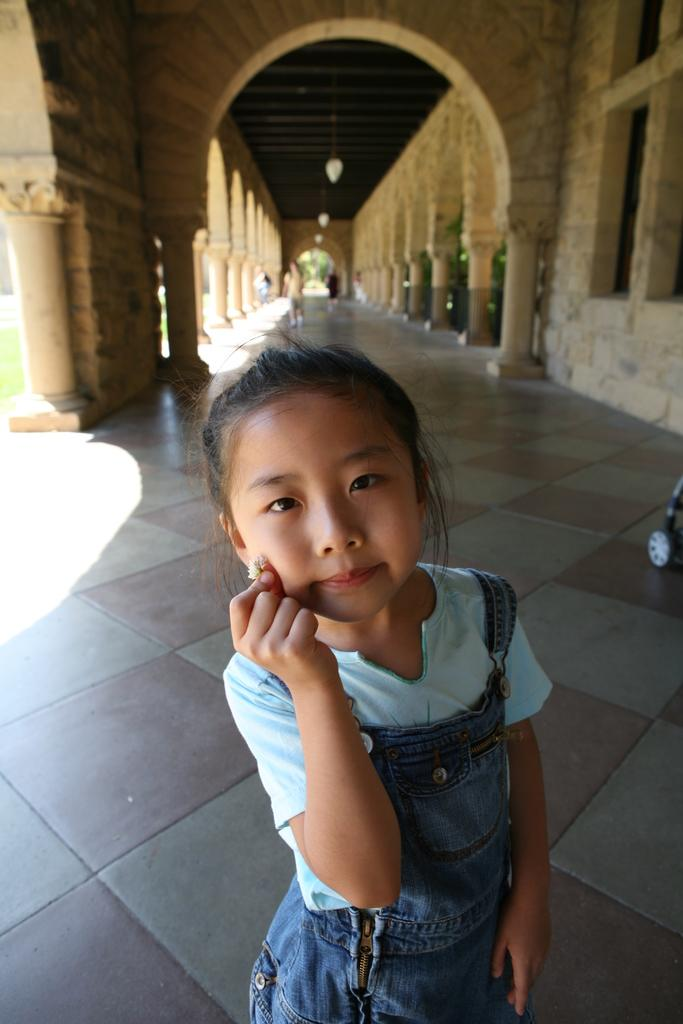What is the main subject of the image? There is a girl standing in the image. What is the girl holding in her hand? The girl is holding an object in her hand. What can be seen behind the girl? There is an arch behind the girl. What is happening on the floor in the image? There are people walking on the floor in the image. What type of committee is meeting under the arch in the image? There is no committee meeting under the arch in the image; it only shows a girl standing and people walking on the floor. How many cherries are visible on the girl's dress in the image? There are no cherries visible on the girl's dress in the image. 